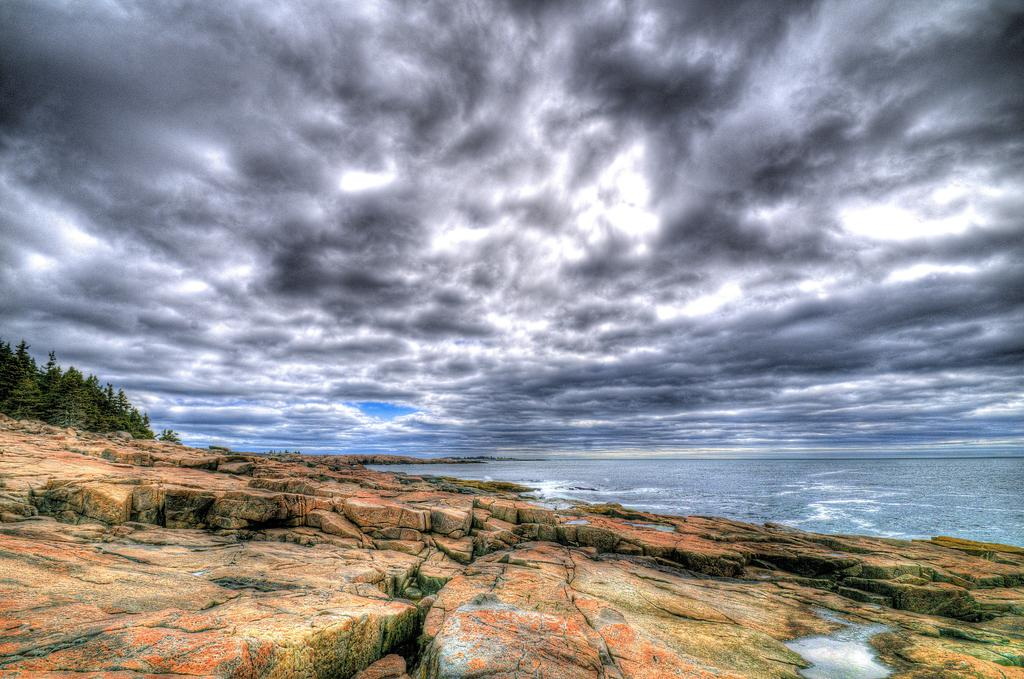What type of natural elements can be seen in the image? There are rocks and trees visible in the image. Where are the trees located in the image? The trees are in the left corner of the image. What else can be seen in the image besides rocks and trees? There is water visible in the image. How would you describe the weather in the image? The sky is cloudy in the image, suggesting a potentially overcast or rainy day. What type of muscle is being flexed by the animal in the image? There is no animal present in the image, and therefore no muscle flexing can be observed. 